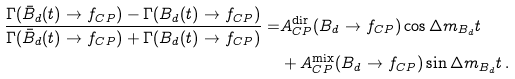<formula> <loc_0><loc_0><loc_500><loc_500>\frac { \Gamma ( \bar { B } _ { d } ( t ) \to f _ { C P } ) - \Gamma ( B _ { d } ( t ) \to f _ { C P } ) } { \Gamma ( \bar { B } _ { d } ( t ) \to f _ { C P } ) + \Gamma ( B _ { d } ( t ) \to f _ { C P } ) } = & A _ { C P } ^ { \text {dir} } ( B _ { d } \to f _ { C P } ) \cos \Delta m _ { B _ { d } } t \\ & + A _ { C P } ^ { \text {mix} } ( B _ { d } \to f _ { C P } ) \sin \Delta m _ { B _ { d } } t \, .</formula> 